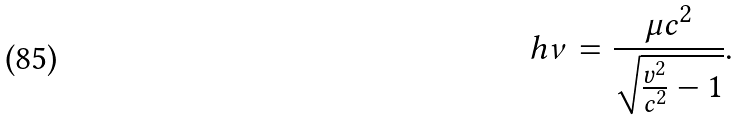Convert formula to latex. <formula><loc_0><loc_0><loc_500><loc_500>h \nu = \frac { \mu c ^ { 2 } } { \sqrt { \frac { v ^ { 2 } } { c ^ { 2 } } - 1 } } .</formula> 